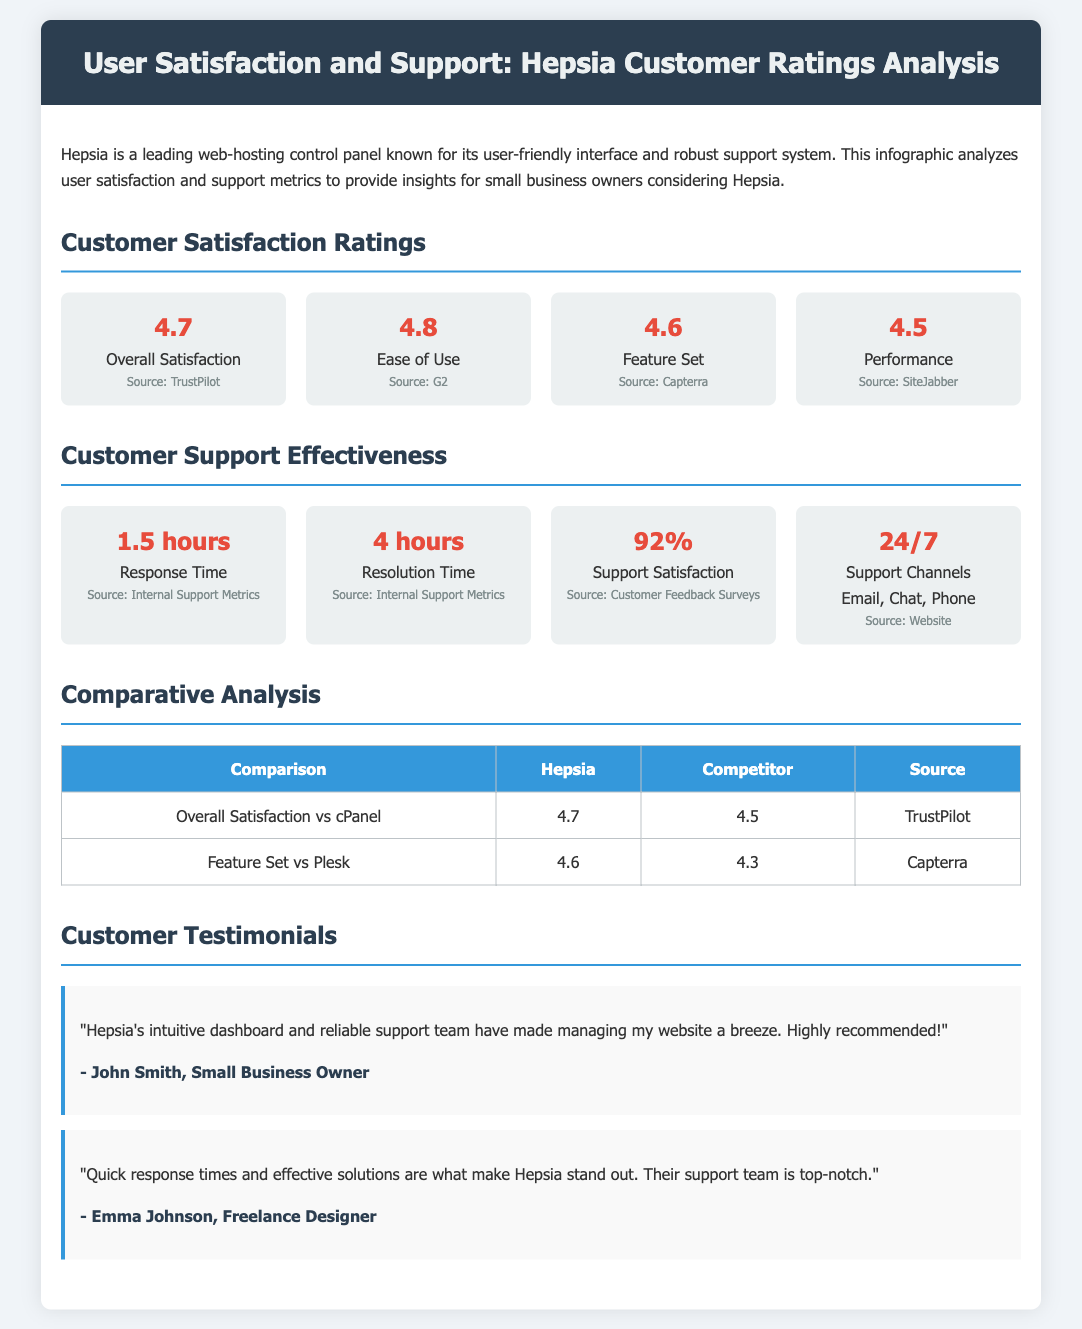What is the overall satisfaction rating for Hepsia? The overall satisfaction rating is listed in the document under Customer Satisfaction Ratings.
Answer: 4.7 What is the average ease of use rating reported? The ease of use rating is categorized under Customer Satisfaction Ratings.
Answer: 4.8 How long does it take for Hepsia to respond to support inquiries? The response time for support inquiries is specified in the Customer Support Effectiveness section.
Answer: 1.5 hours What percentage of customers are satisfied with the support provided? The support satisfaction percentage is provided in the Customer Support Effectiveness section.
Answer: 92% What is Hepsia's performance rating? The performance rating is found in the Customer Satisfaction Ratings section.
Answer: 4.5 How does Hepsia's overall satisfaction compare to cPanel's? The comparison is detailed in the Comparative Analysis section, showing the ratings for both services.
Answer: 4.7 vs 4.5 How many support channels does Hepsia offer? The number of support channels is mentioned in the Customer Support Effectiveness section.
Answer: 24/7 Who authored a testimonial praising Hepsia's intuitive dashboard? The authors of the testimonials are presented in the Customer Testimonials section.
Answer: John Smith What is the feature set rating for Hepsia? The feature set rating is included in the Customer Satisfaction Ratings section.
Answer: 4.6 